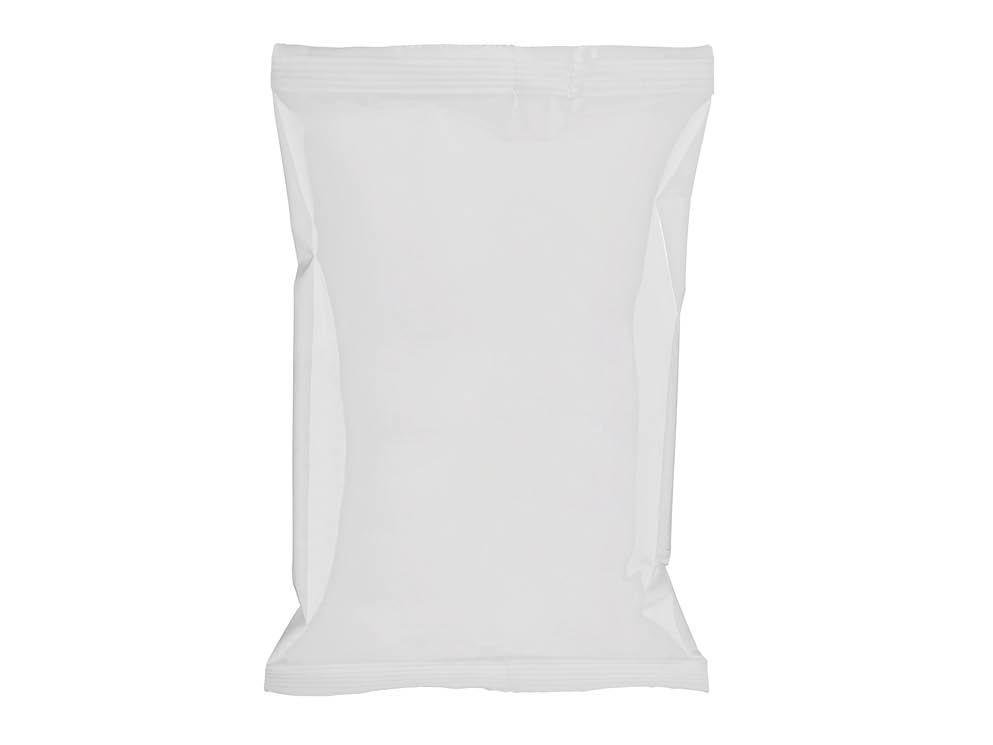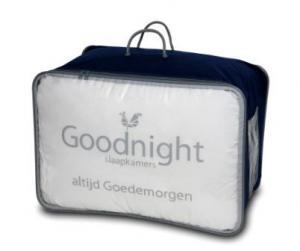The first image is the image on the left, the second image is the image on the right. For the images shown, is this caption "There are 2 white pillows in bags with handles." true? Answer yes or no. No. The first image is the image on the left, the second image is the image on the right. Analyze the images presented: Is the assertion "Each image shows a bag that holds a pillow, at least one bag is transparent, and the bag on the right has double handles." valid? Answer yes or no. No. 